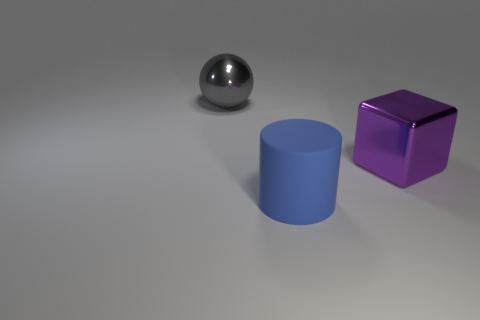Add 3 big cyan matte things. How many objects exist? 6 Subtract all blocks. How many objects are left? 2 Add 3 big balls. How many big balls exist? 4 Subtract 0 yellow cubes. How many objects are left? 3 Subtract all large blue objects. Subtract all tiny purple rubber objects. How many objects are left? 2 Add 1 big gray objects. How many big gray objects are left? 2 